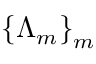<formula> <loc_0><loc_0><loc_500><loc_500>\left \{ \Lambda _ { m } \right \} _ { m }</formula> 